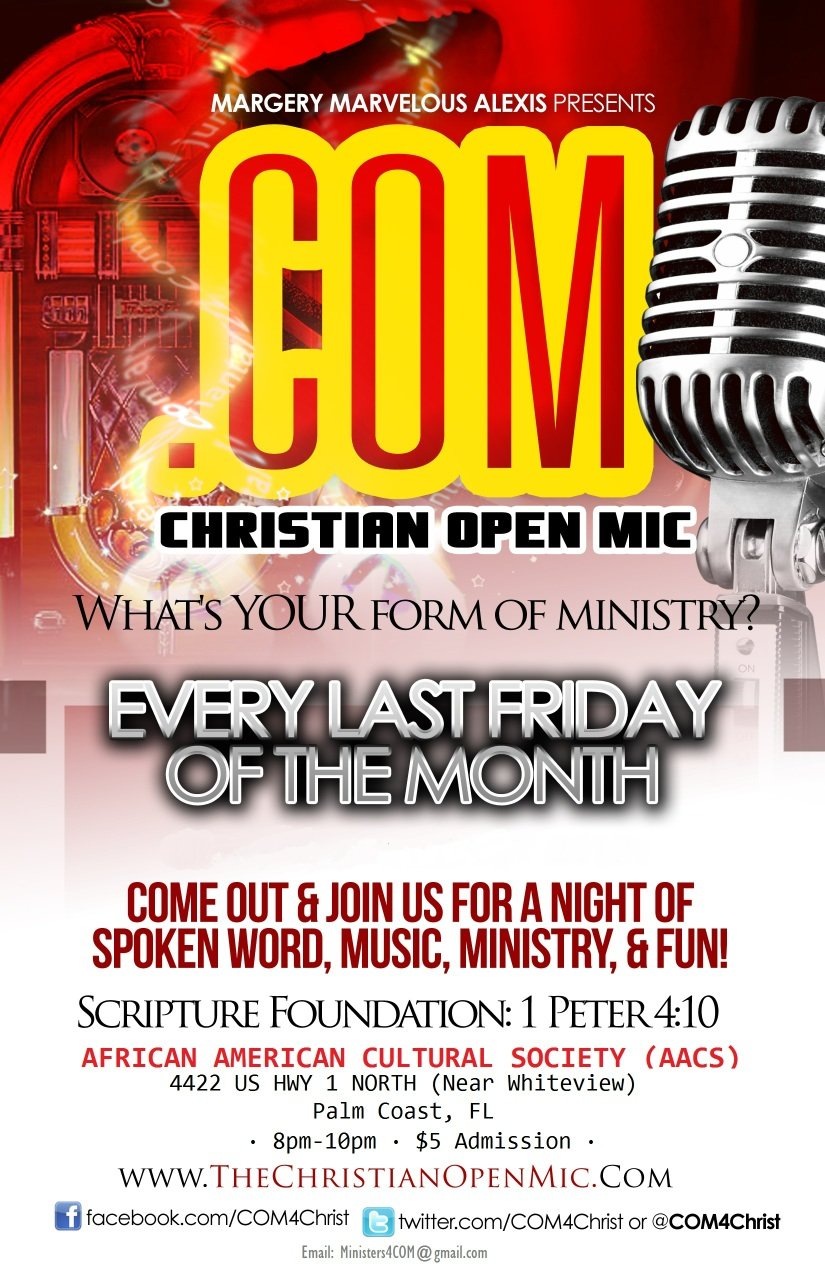What makes the Christian Open Mic event unique compared to other cultural events? The Christian Open Mic event is unique in its focus on faith-based artistic expression. Unlike other cultural events that might celebrate a broader spectrum of arts and traditions, this event specifically encourages performances and activities rooted in Christian faith and ministry. This blend of spirituality and creativity provides a unique space for participants to connect with others, share their talents, and grow in their faith. 